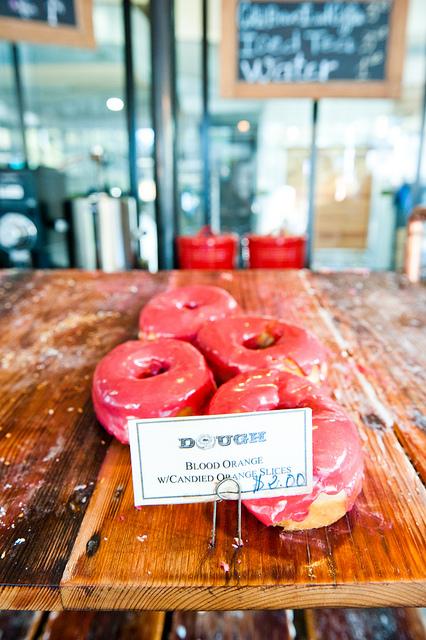How much does a doughnut cost?
Write a very short answer. 2.00. How many donuts?
Quick response, please. 4. What color are the donuts?
Quick response, please. Pink. How much does one donut cost?
Quick response, please. 2.00. 